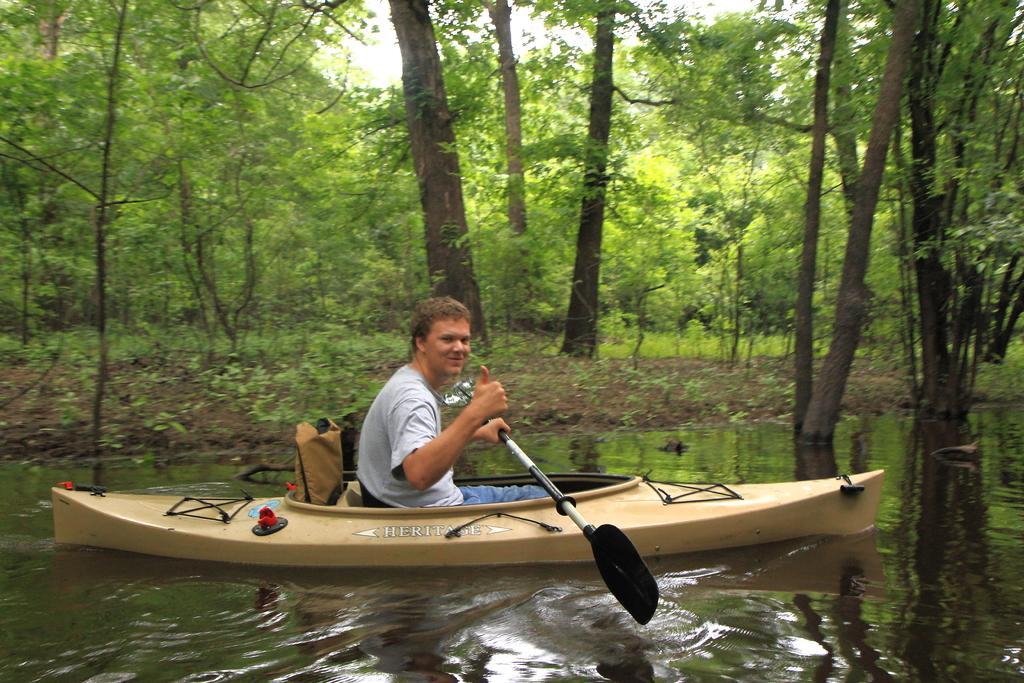How would you summarize this image in a sentence or two? In this picture we can see a person sitting on a boat. He is holding a paddle in his hand. This boat is in water. We can see a few trees in the background. 